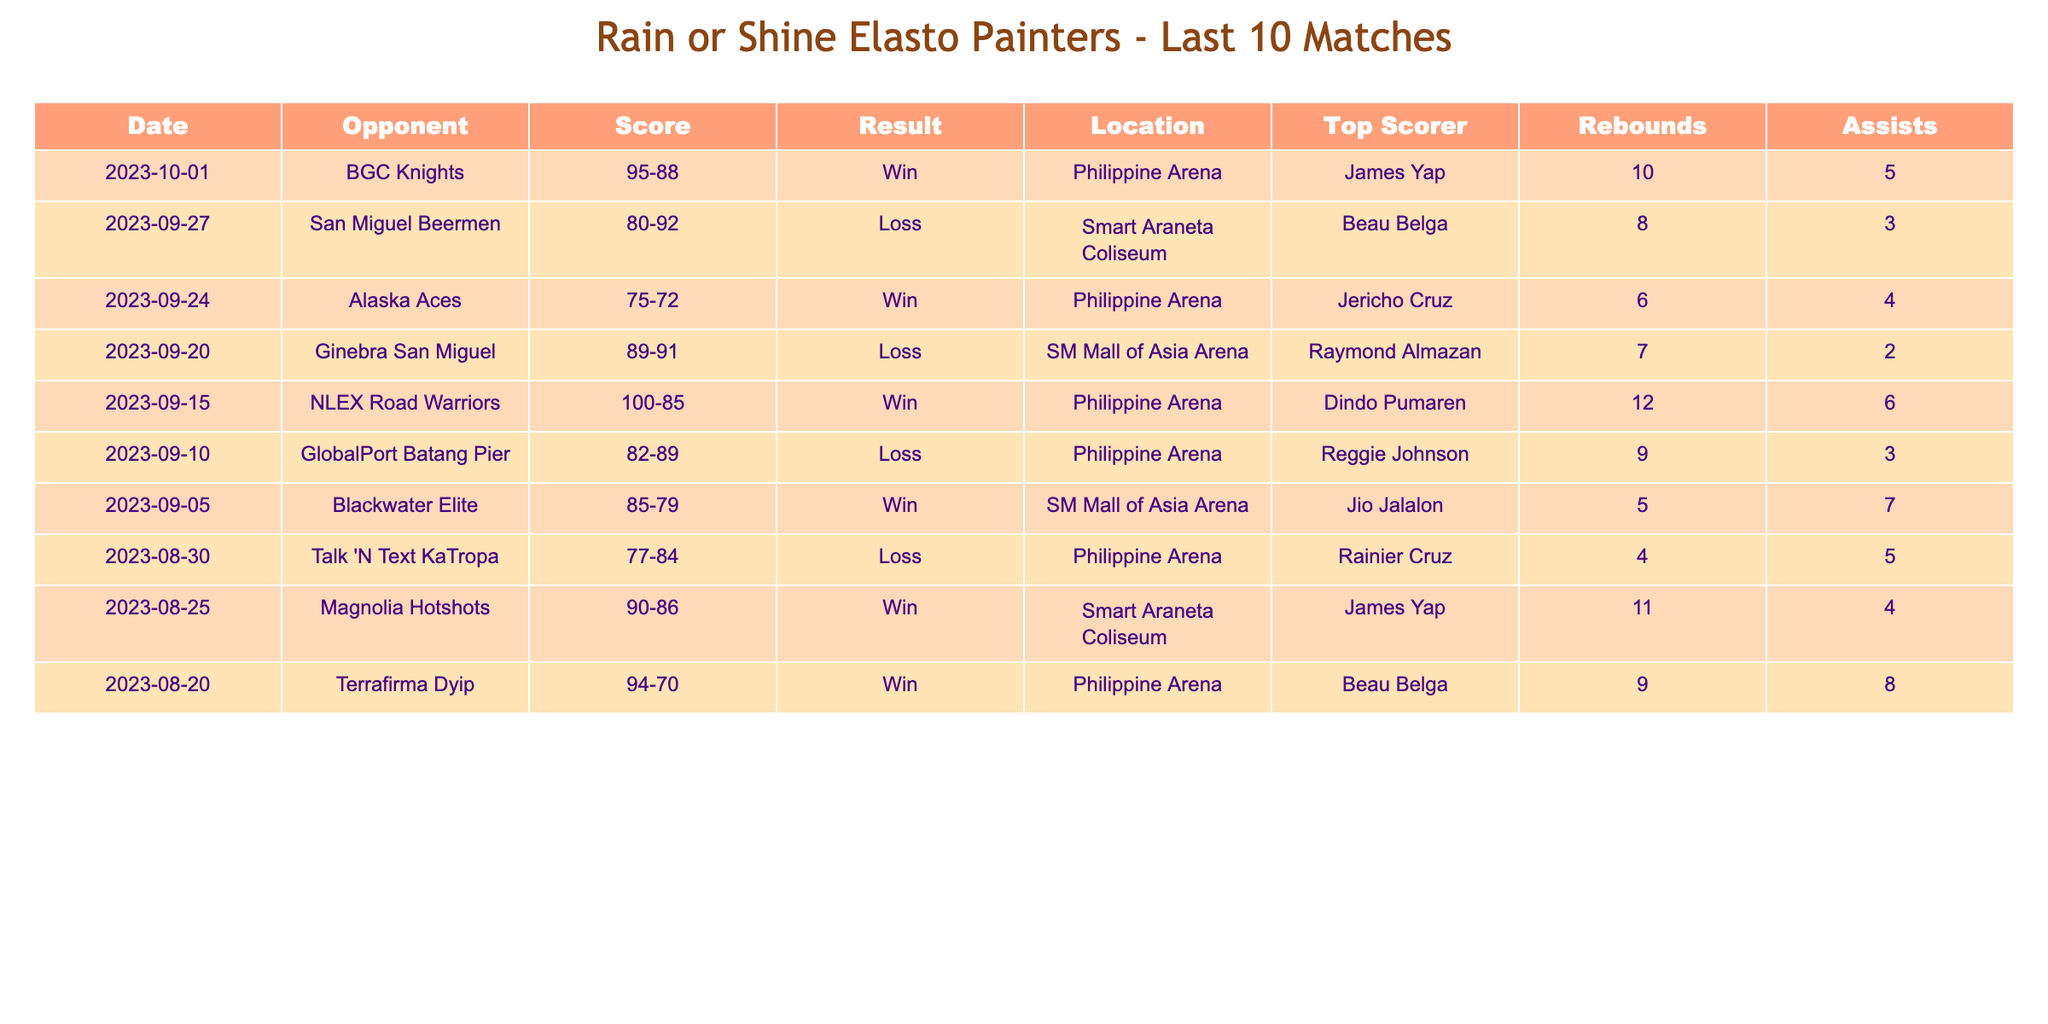What was the result of the game against the BGC Knights? The table indicates that the game against the BGC Knights was played on October 1, 2023, and Rain or Shine Elasto Painters won with a score of 95-88.
Answer: Win Who was the top scorer in the match against Alaska Aces? By looking at the entry for the game against the Alaska Aces on September 24, 2023, the top scorer was Jericho Cruz, who scored 6 points in that match.
Answer: Jericho Cruz What is the total number of wins Rain or Shine Elasto Painters secured in the last 10 matches? The table presents 10 matches with different outcomes; they won 5 matches: against BGC Knights, Alaska Aces, NLEX Road Warriors, Blackwater Elite, and Magnolia Hotshots. Adding these gives a total of 5 wins.
Answer: 5 Did Rain or Shine Elasto Painters win against San Miguel Beermen? The table shows that in the match against the San Miguel Beermen on September 27, 2023, they lost with a score of 80-92.
Answer: No What is the average number of rebounds in wins? The matches that resulted in wins were against BGC Knights (5 rebounds), Alaska Aces (4 rebounds), NLEX Road Warriors (6 rebounds), Blackwater Elite (7 rebounds), and Magnolia Hotshots (4 rebounds). Summing these rebounds gives 5 + 4 + 6 + 7 + 4 = 26. Dividing by the number of wins (5), the average rebounds in wins is 26/5 = 5.2.
Answer: 5.2 How many points did Beau Belga score in the game against Terrafirma Dyip? The table shows that in the match against Terrafirma Dyip on August 20, 2023, Beau Belga was the top scorer with 9 points.
Answer: 9 Which opponent had the highest score against Rain or Shine Elasto Painters? By reviewing the scores in the loss columns, the highest scoring opponent was San Miguel Beermen, who scored 92 points in their match against Rain or Shine Elasto Painters on September 27, 2023.
Answer: San Miguel Beermen (92 points) What was the total score of Rain or Shine Elasto Painters in their last match? In the last match reported, Rain or Shine Elasto Painters faced Terrafirma Dyip on August 20, 2023, scoring a total of 94 points.
Answer: 94 